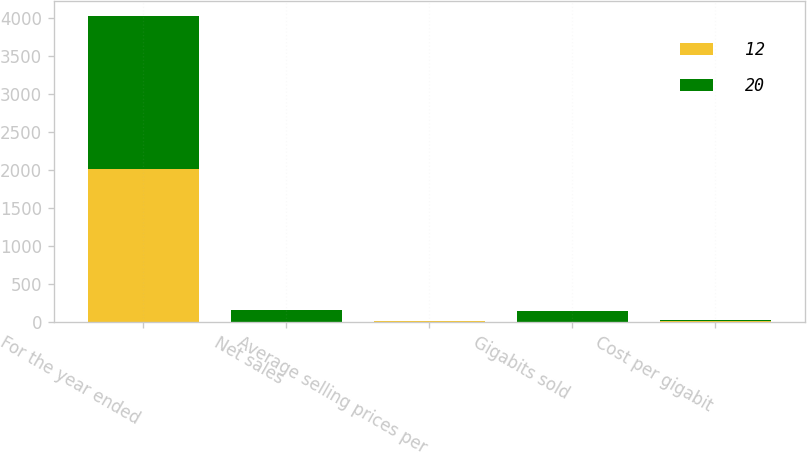Convert chart to OTSL. <chart><loc_0><loc_0><loc_500><loc_500><stacked_bar_chart><ecel><fcel>For the year ended<fcel>Net sales<fcel>Average selling prices per<fcel>Gigabits sold<fcel>Cost per gigabit<nl><fcel>12<fcel>2015<fcel>7<fcel>11<fcel>4<fcel>12<nl><fcel>20<fcel>2014<fcel>156<fcel>6<fcel>142<fcel>20<nl></chart> 